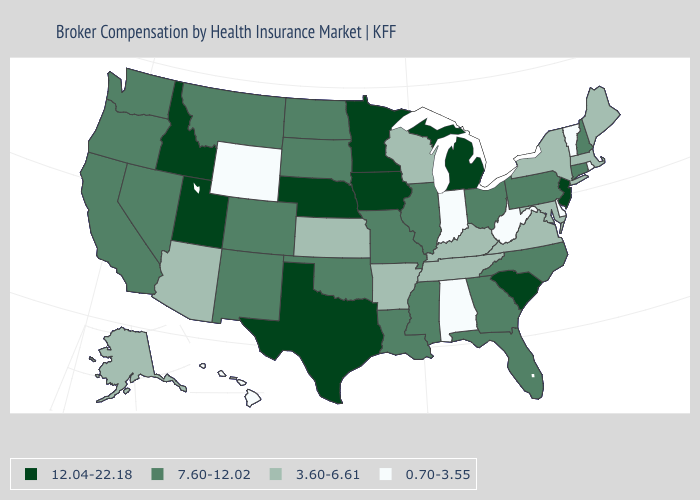Does the map have missing data?
Answer briefly. No. Name the states that have a value in the range 3.60-6.61?
Quick response, please. Alaska, Arizona, Arkansas, Kansas, Kentucky, Maine, Maryland, Massachusetts, New York, Tennessee, Virginia, Wisconsin. What is the lowest value in states that border North Carolina?
Give a very brief answer. 3.60-6.61. How many symbols are there in the legend?
Concise answer only. 4. What is the highest value in the USA?
Give a very brief answer. 12.04-22.18. Name the states that have a value in the range 12.04-22.18?
Be succinct. Idaho, Iowa, Michigan, Minnesota, Nebraska, New Jersey, South Carolina, Texas, Utah. Among the states that border New Hampshire , does Vermont have the lowest value?
Short answer required. Yes. Does Maine have the lowest value in the Northeast?
Give a very brief answer. No. What is the value of New Mexico?
Give a very brief answer. 7.60-12.02. Is the legend a continuous bar?
Quick response, please. No. Name the states that have a value in the range 7.60-12.02?
Answer briefly. California, Colorado, Connecticut, Florida, Georgia, Illinois, Louisiana, Mississippi, Missouri, Montana, Nevada, New Hampshire, New Mexico, North Carolina, North Dakota, Ohio, Oklahoma, Oregon, Pennsylvania, South Dakota, Washington. Name the states that have a value in the range 3.60-6.61?
Short answer required. Alaska, Arizona, Arkansas, Kansas, Kentucky, Maine, Maryland, Massachusetts, New York, Tennessee, Virginia, Wisconsin. Which states have the lowest value in the USA?
Write a very short answer. Alabama, Delaware, Hawaii, Indiana, Rhode Island, Vermont, West Virginia, Wyoming. What is the highest value in states that border Tennessee?
Concise answer only. 7.60-12.02. Does the first symbol in the legend represent the smallest category?
Quick response, please. No. 